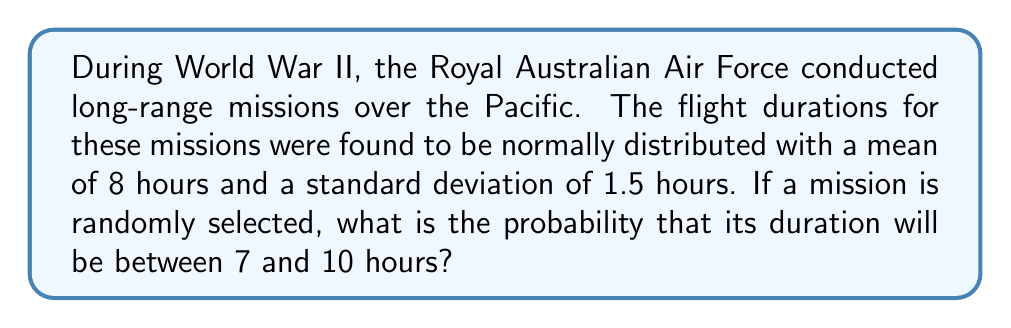Solve this math problem. To solve this problem, we'll use the properties of the normal distribution and the z-score formula.

Step 1: Identify the given information
- Mean (μ) = 8 hours
- Standard deviation (σ) = 1.5 hours
- Lower bound = 7 hours
- Upper bound = 10 hours

Step 2: Calculate the z-scores for the lower and upper bounds
z-score formula: $z = \frac{x - \mu}{\sigma}$

For lower bound:
$z_1 = \frac{7 - 8}{1.5} = -\frac{2}{3} \approx -0.67$

For upper bound:
$z_2 = \frac{10 - 8}{1.5} = \frac{4}{3} \approx 1.33$

Step 3: Find the area under the standard normal curve between these z-scores
We need to find P(-0.67 < Z < 1.33)

This can be calculated using the standard normal distribution table or a calculator:

P(Z < 1.33) - P(Z < -0.67)
= 0.9082 - 0.2514
= 0.6568

Step 4: Convert to percentage
0.6568 * 100% = 65.68%

Therefore, the probability that a randomly selected mission will have a duration between 7 and 10 hours is approximately 65.68%.
Answer: 65.68% 